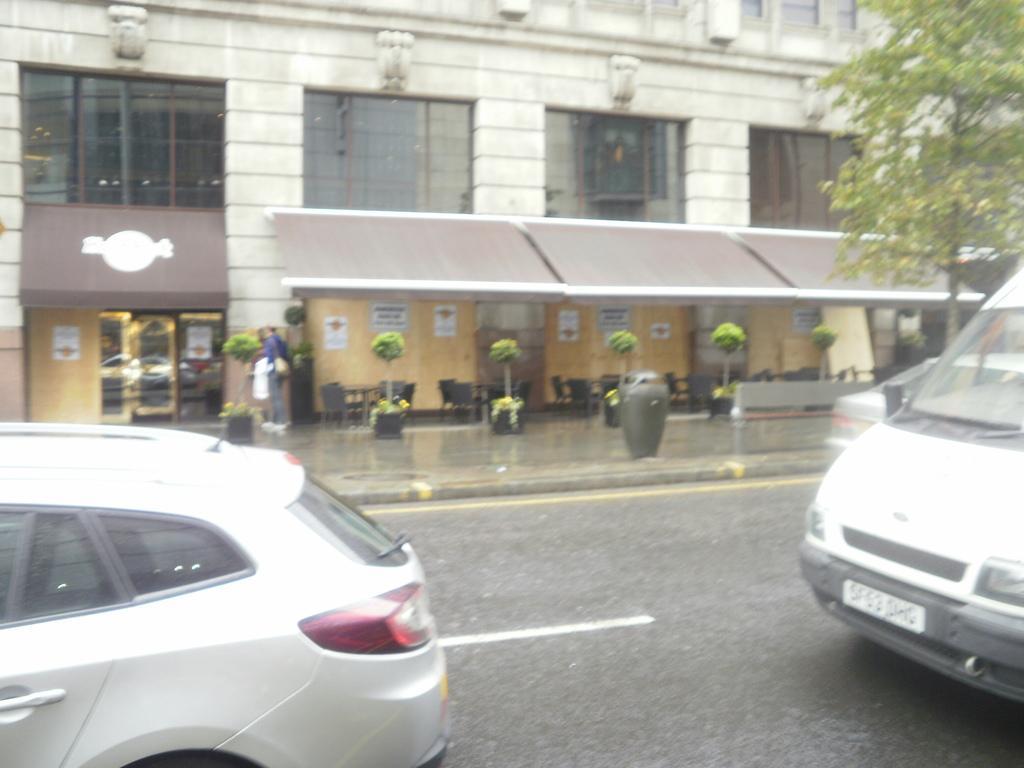How would you summarize this image in a sentence or two? In this image I can see few vehicles on the road, in front the vehicle is in white color. Background I can see the person standing wearing blue shirt, gray pant and I can see plants and trees in green color and the building is in white color and I can see few glass windows. 